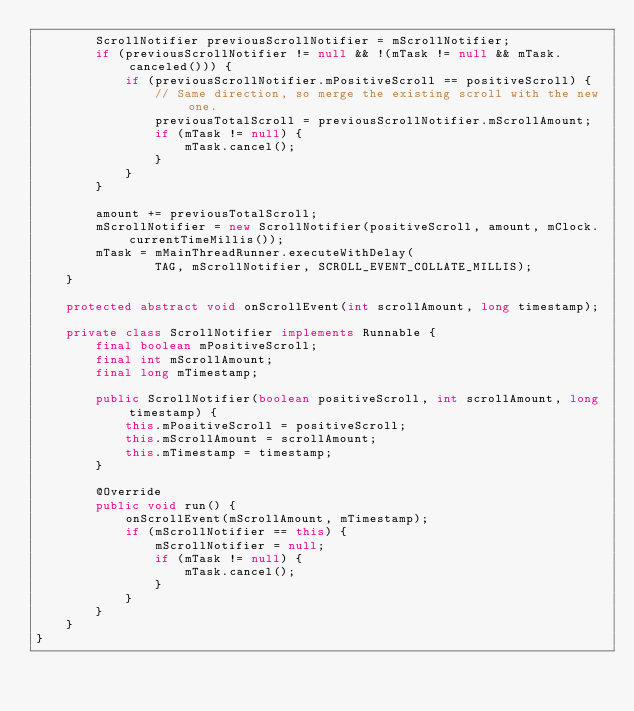Convert code to text. <code><loc_0><loc_0><loc_500><loc_500><_Java_>        ScrollNotifier previousScrollNotifier = mScrollNotifier;
        if (previousScrollNotifier != null && !(mTask != null && mTask.canceled())) {
            if (previousScrollNotifier.mPositiveScroll == positiveScroll) {
                // Same direction, so merge the existing scroll with the new one.
                previousTotalScroll = previousScrollNotifier.mScrollAmount;
                if (mTask != null) {
                    mTask.cancel();
                }
            }
        }

        amount += previousTotalScroll;
        mScrollNotifier = new ScrollNotifier(positiveScroll, amount, mClock.currentTimeMillis());
        mTask = mMainThreadRunner.executeWithDelay(
                TAG, mScrollNotifier, SCROLL_EVENT_COLLATE_MILLIS);
    }

    protected abstract void onScrollEvent(int scrollAmount, long timestamp);

    private class ScrollNotifier implements Runnable {
        final boolean mPositiveScroll;
        final int mScrollAmount;
        final long mTimestamp;

        public ScrollNotifier(boolean positiveScroll, int scrollAmount, long timestamp) {
            this.mPositiveScroll = positiveScroll;
            this.mScrollAmount = scrollAmount;
            this.mTimestamp = timestamp;
        }

        @Override
        public void run() {
            onScrollEvent(mScrollAmount, mTimestamp);
            if (mScrollNotifier == this) {
                mScrollNotifier = null;
                if (mTask != null) {
                    mTask.cancel();
                }
            }
        }
    }
}
</code> 